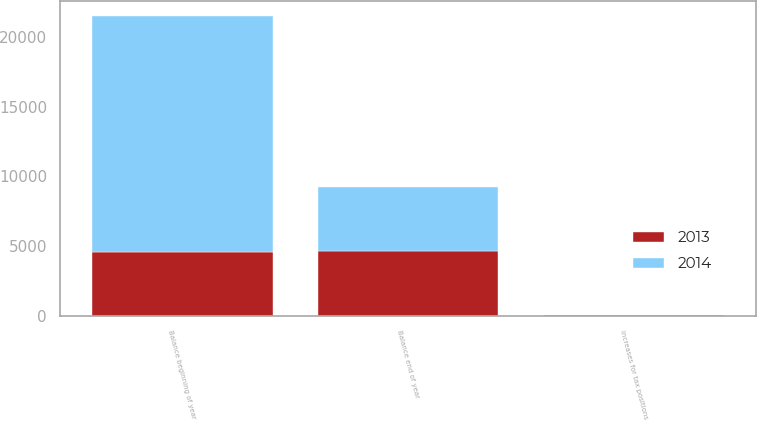Convert chart to OTSL. <chart><loc_0><loc_0><loc_500><loc_500><stacked_bar_chart><ecel><fcel>Balance beginning of year<fcel>Increases for tax positions<fcel>Balance end of year<nl><fcel>2013<fcel>4590<fcel>59<fcel>4649<nl><fcel>2014<fcel>16890<fcel>15<fcel>4590<nl></chart> 